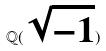Convert formula to latex. <formula><loc_0><loc_0><loc_500><loc_500>\mathbb { Q } ( \sqrt { - 1 } )</formula> 